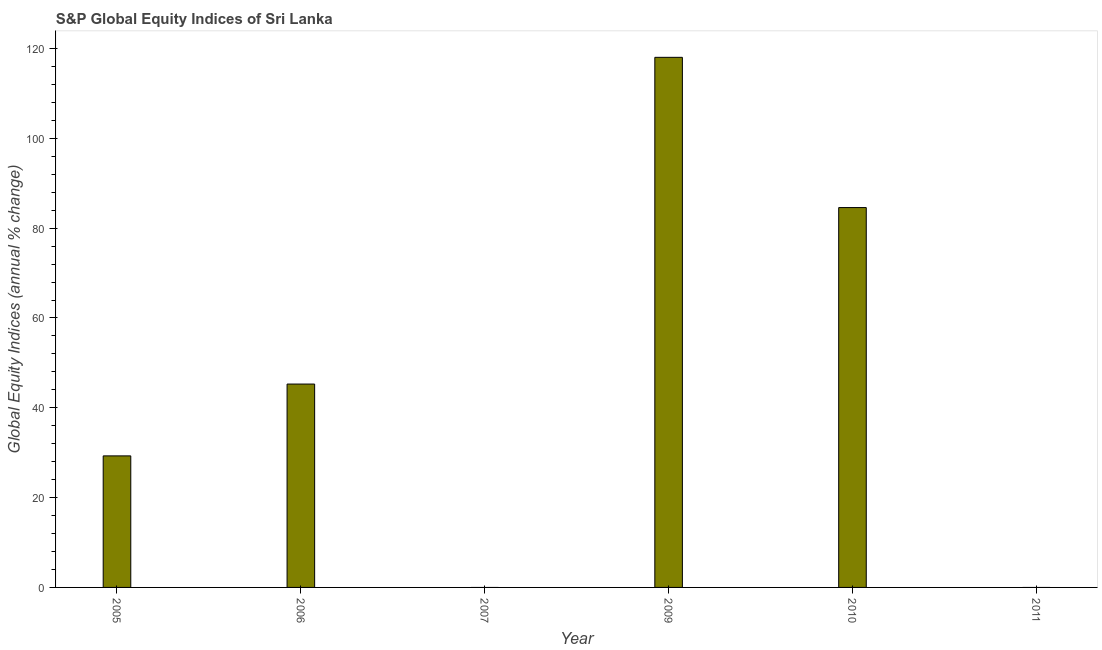What is the title of the graph?
Provide a succinct answer. S&P Global Equity Indices of Sri Lanka. What is the label or title of the X-axis?
Give a very brief answer. Year. What is the label or title of the Y-axis?
Your response must be concise. Global Equity Indices (annual % change). What is the s&p global equity indices in 2006?
Your answer should be very brief. 45.29. Across all years, what is the maximum s&p global equity indices?
Ensure brevity in your answer.  118.05. Across all years, what is the minimum s&p global equity indices?
Offer a very short reply. 0. In which year was the s&p global equity indices maximum?
Offer a terse response. 2009. What is the sum of the s&p global equity indices?
Provide a short and direct response. 277.22. What is the difference between the s&p global equity indices in 2006 and 2009?
Keep it short and to the point. -72.76. What is the average s&p global equity indices per year?
Your answer should be very brief. 46.2. What is the median s&p global equity indices?
Provide a short and direct response. 37.29. What is the ratio of the s&p global equity indices in 2005 to that in 2010?
Your answer should be very brief. 0.35. Is the s&p global equity indices in 2006 less than that in 2010?
Your response must be concise. Yes. Is the difference between the s&p global equity indices in 2006 and 2010 greater than the difference between any two years?
Provide a succinct answer. No. What is the difference between the highest and the second highest s&p global equity indices?
Provide a succinct answer. 33.46. What is the difference between the highest and the lowest s&p global equity indices?
Your answer should be compact. 118.05. In how many years, is the s&p global equity indices greater than the average s&p global equity indices taken over all years?
Provide a short and direct response. 2. How many bars are there?
Your answer should be very brief. 4. Are all the bars in the graph horizontal?
Your answer should be very brief. No. How many years are there in the graph?
Ensure brevity in your answer.  6. Are the values on the major ticks of Y-axis written in scientific E-notation?
Your answer should be very brief. No. What is the Global Equity Indices (annual % change) of 2005?
Ensure brevity in your answer.  29.29. What is the Global Equity Indices (annual % change) in 2006?
Your answer should be compact. 45.29. What is the Global Equity Indices (annual % change) in 2007?
Your answer should be very brief. 0. What is the Global Equity Indices (annual % change) in 2009?
Your response must be concise. 118.05. What is the Global Equity Indices (annual % change) of 2010?
Your response must be concise. 84.59. What is the Global Equity Indices (annual % change) of 2011?
Your response must be concise. 0. What is the difference between the Global Equity Indices (annual % change) in 2005 and 2006?
Ensure brevity in your answer.  -16. What is the difference between the Global Equity Indices (annual % change) in 2005 and 2009?
Your answer should be very brief. -88.76. What is the difference between the Global Equity Indices (annual % change) in 2005 and 2010?
Make the answer very short. -55.3. What is the difference between the Global Equity Indices (annual % change) in 2006 and 2009?
Make the answer very short. -72.76. What is the difference between the Global Equity Indices (annual % change) in 2006 and 2010?
Ensure brevity in your answer.  -39.3. What is the difference between the Global Equity Indices (annual % change) in 2009 and 2010?
Provide a succinct answer. 33.46. What is the ratio of the Global Equity Indices (annual % change) in 2005 to that in 2006?
Keep it short and to the point. 0.65. What is the ratio of the Global Equity Indices (annual % change) in 2005 to that in 2009?
Ensure brevity in your answer.  0.25. What is the ratio of the Global Equity Indices (annual % change) in 2005 to that in 2010?
Provide a succinct answer. 0.35. What is the ratio of the Global Equity Indices (annual % change) in 2006 to that in 2009?
Keep it short and to the point. 0.38. What is the ratio of the Global Equity Indices (annual % change) in 2006 to that in 2010?
Offer a very short reply. 0.54. What is the ratio of the Global Equity Indices (annual % change) in 2009 to that in 2010?
Offer a terse response. 1.4. 